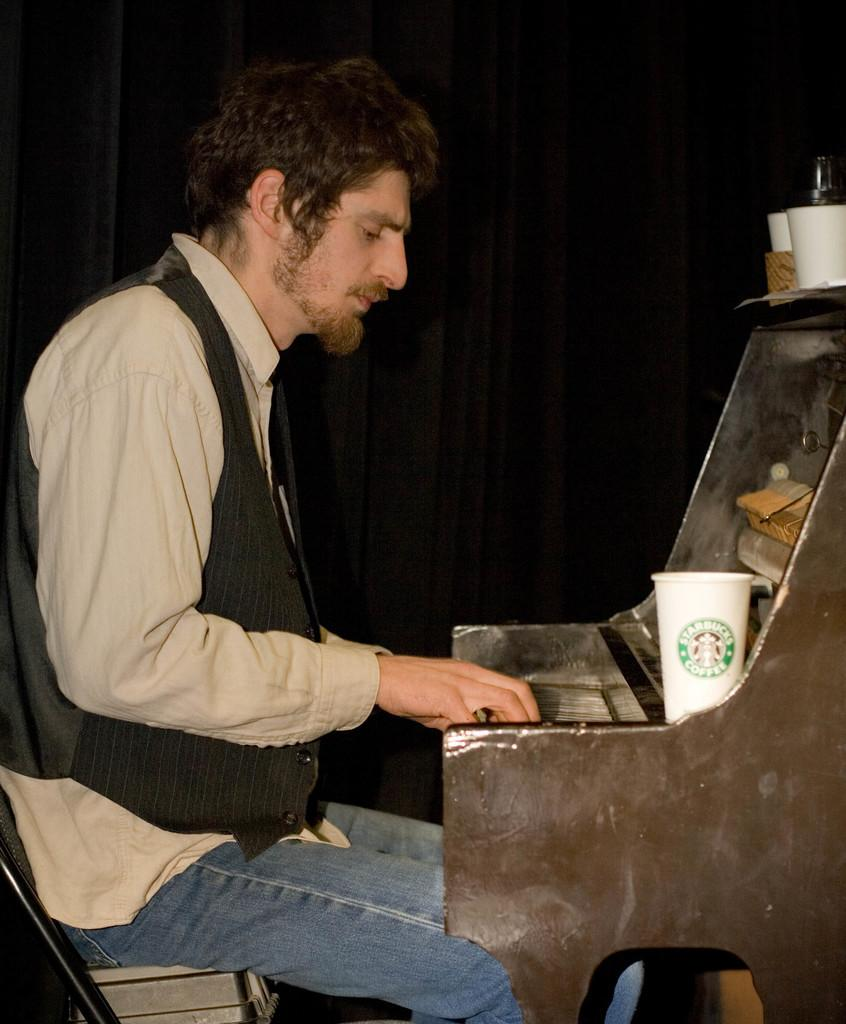What is the person in the image doing? The person is sitting on a chair in the image. What can be seen in front of the person? There is a musical instrument in front of the person. What is on the cup in the image? There are objects on the cup in the image. What color is the background of the image? The background of the image is black. What month is it in the image? The month cannot be determined from the image, as there is no information about the time or date. Can you see a goat in the image? There is no goat present in the image. 